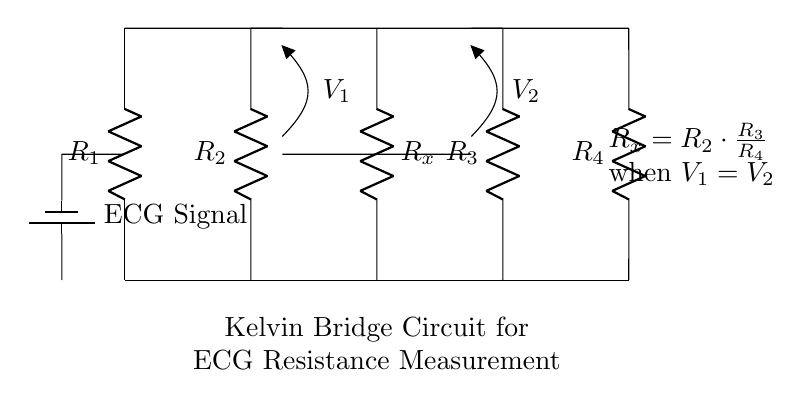What type of circuit is this? This circuit is a Kelvin bridge, which is used for precise resistance measurements in applications like ECG machines. The structure consists of four resistors and two voltage indicators.
Answer: Kelvin bridge What is the purpose of this circuit? The main purpose of the Kelvin bridge circuit is to measure unknown resistance accurately by balancing the bridge to find the value of the unknown resistor based on known resistances.
Answer: Accurate resistance measurement What is indicated by the voltage indicators V1 and V2? V1 and V2 indicate the potential differences across the sections of the bridge, which are essential for determining when the bridge is balanced (i.e., V1 equals V2). This condition helps find the unknown resistance.
Answer: Potential differences Which resistors are used for balancing the circuit? The resistors used for balancing the circuit are R2 and R3. Their values are adjusted until the voltages V1 and V2 are equal, indicating that the bridge is balanced.
Answer: R2 and R3 What is the relationship for calculating the unknown resistance R_x? The relationship is stated in the circuit: R_x equals R2 multiplied by the ratio of R3 to R4 when V1 equals V2, allowing the calculation of R_x based on the known resistors.
Answer: R_x equals R2 times R3 over R4 What condition signifies that the bridge is balanced? The bridge is balanced when the voltages V1 and V2 are equal, indicating no current flows through the measurement points. This is a crucial condition for accurate resistance measurement.
Answer: V1 equals V2 What does R_x represent in this circuit? R_x represents the unknown resistance that is being measured in the Kelvin bridge circuit. It’s the target resistance we aim to find using the balance condition.
Answer: Unknown resistance 